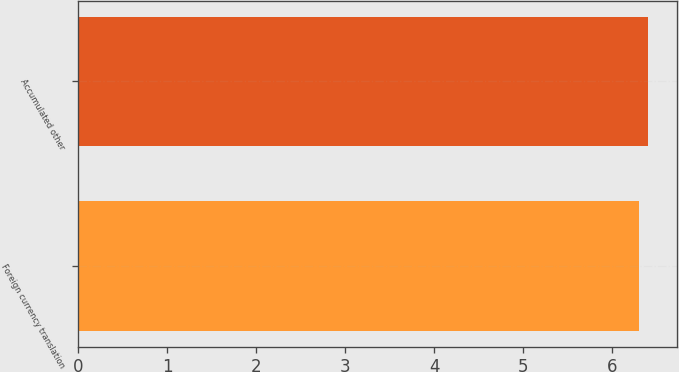Convert chart. <chart><loc_0><loc_0><loc_500><loc_500><bar_chart><fcel>Foreign currency translation<fcel>Accumulated other<nl><fcel>6.3<fcel>6.4<nl></chart> 